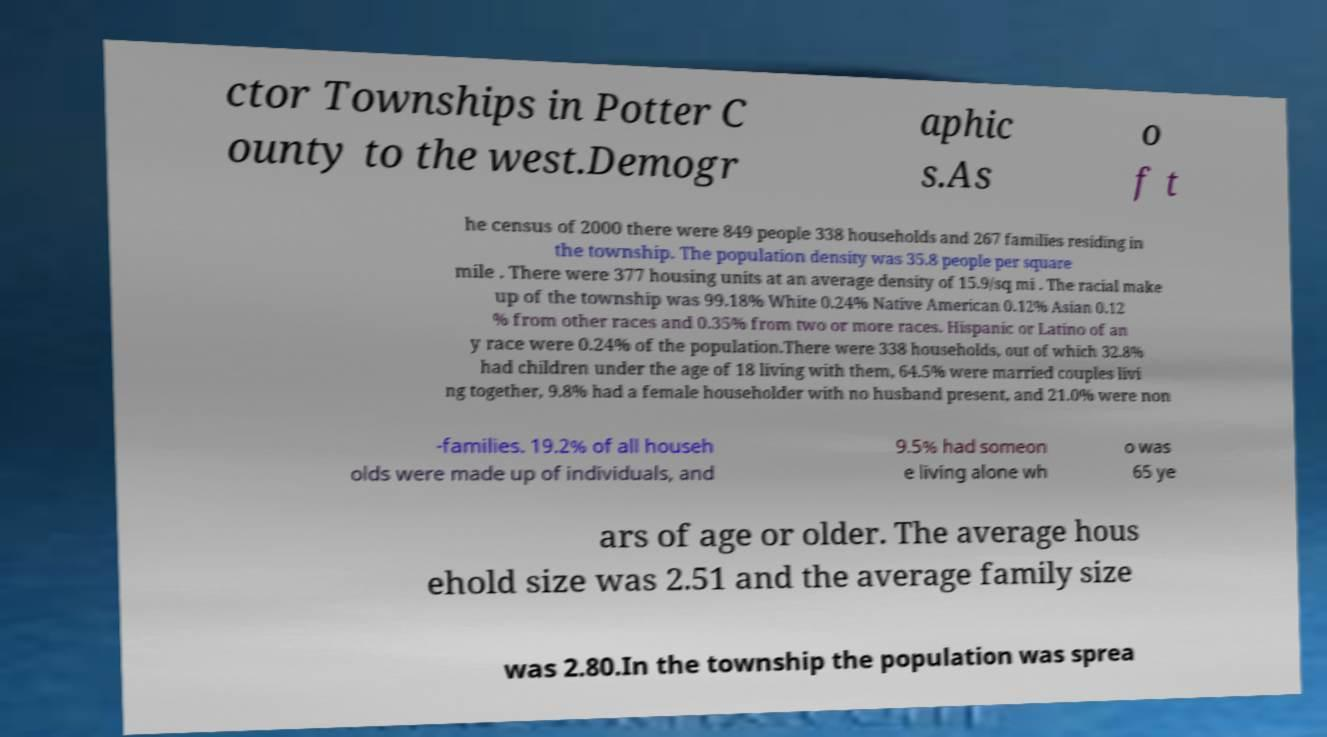Could you assist in decoding the text presented in this image and type it out clearly? ctor Townships in Potter C ounty to the west.Demogr aphic s.As o f t he census of 2000 there were 849 people 338 households and 267 families residing in the township. The population density was 35.8 people per square mile . There were 377 housing units at an average density of 15.9/sq mi . The racial make up of the township was 99.18% White 0.24% Native American 0.12% Asian 0.12 % from other races and 0.35% from two or more races. Hispanic or Latino of an y race were 0.24% of the population.There were 338 households, out of which 32.8% had children under the age of 18 living with them, 64.5% were married couples livi ng together, 9.8% had a female householder with no husband present, and 21.0% were non -families. 19.2% of all househ olds were made up of individuals, and 9.5% had someon e living alone wh o was 65 ye ars of age or older. The average hous ehold size was 2.51 and the average family size was 2.80.In the township the population was sprea 